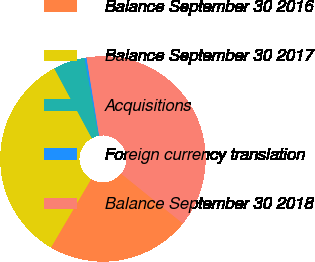Convert chart to OTSL. <chart><loc_0><loc_0><loc_500><loc_500><pie_chart><fcel>Balance September 30 2016<fcel>Balance September 30 2017<fcel>Acquisitions<fcel>Foreign currency translation<fcel>Balance September 30 2018<nl><fcel>22.64%<fcel>33.7%<fcel>4.99%<fcel>0.32%<fcel>38.36%<nl></chart> 